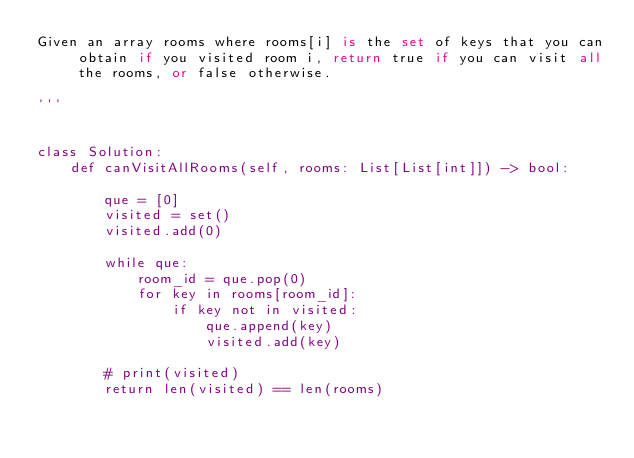Convert code to text. <code><loc_0><loc_0><loc_500><loc_500><_Python_>Given an array rooms where rooms[i] is the set of keys that you can obtain if you visited room i, return true if you can visit all the rooms, or false otherwise.

'''


class Solution:
    def canVisitAllRooms(self, rooms: List[List[int]]) -> bool:

        que = [0]
        visited = set()
        visited.add(0)

        while que:
            room_id = que.pop(0)
            for key in rooms[room_id]:
                if key not in visited:
                    que.append(key)
                    visited.add(key)

        # print(visited)
        return len(visited) == len(rooms)</code> 